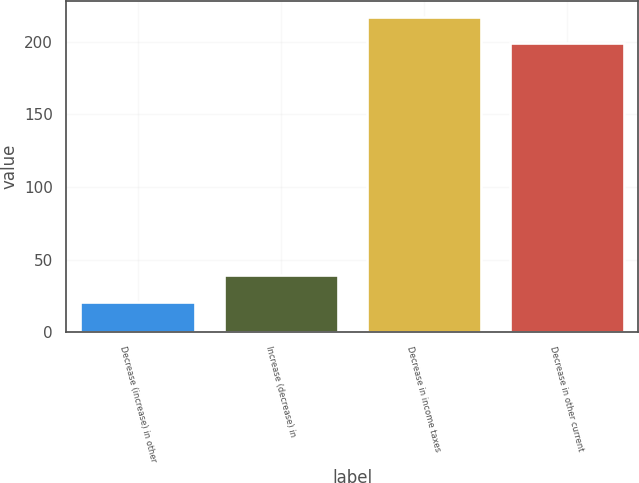Convert chart to OTSL. <chart><loc_0><loc_0><loc_500><loc_500><bar_chart><fcel>Decrease (increase) in other<fcel>Increase (decrease) in<fcel>Decrease in income taxes<fcel>Decrease in other current<nl><fcel>21<fcel>39.2<fcel>217.2<fcel>199<nl></chart> 